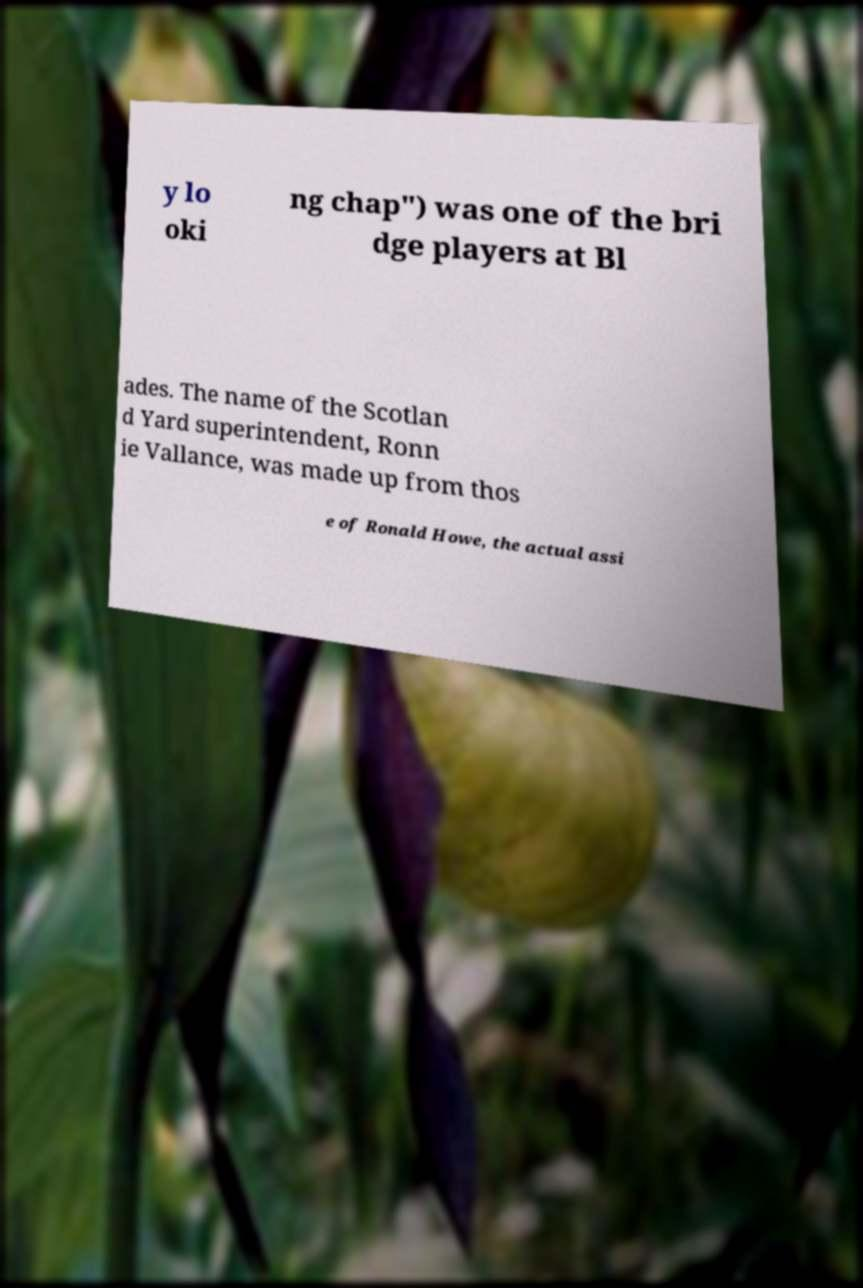Could you assist in decoding the text presented in this image and type it out clearly? y lo oki ng chap") was one of the bri dge players at Bl ades. The name of the Scotlan d Yard superintendent, Ronn ie Vallance, was made up from thos e of Ronald Howe, the actual assi 